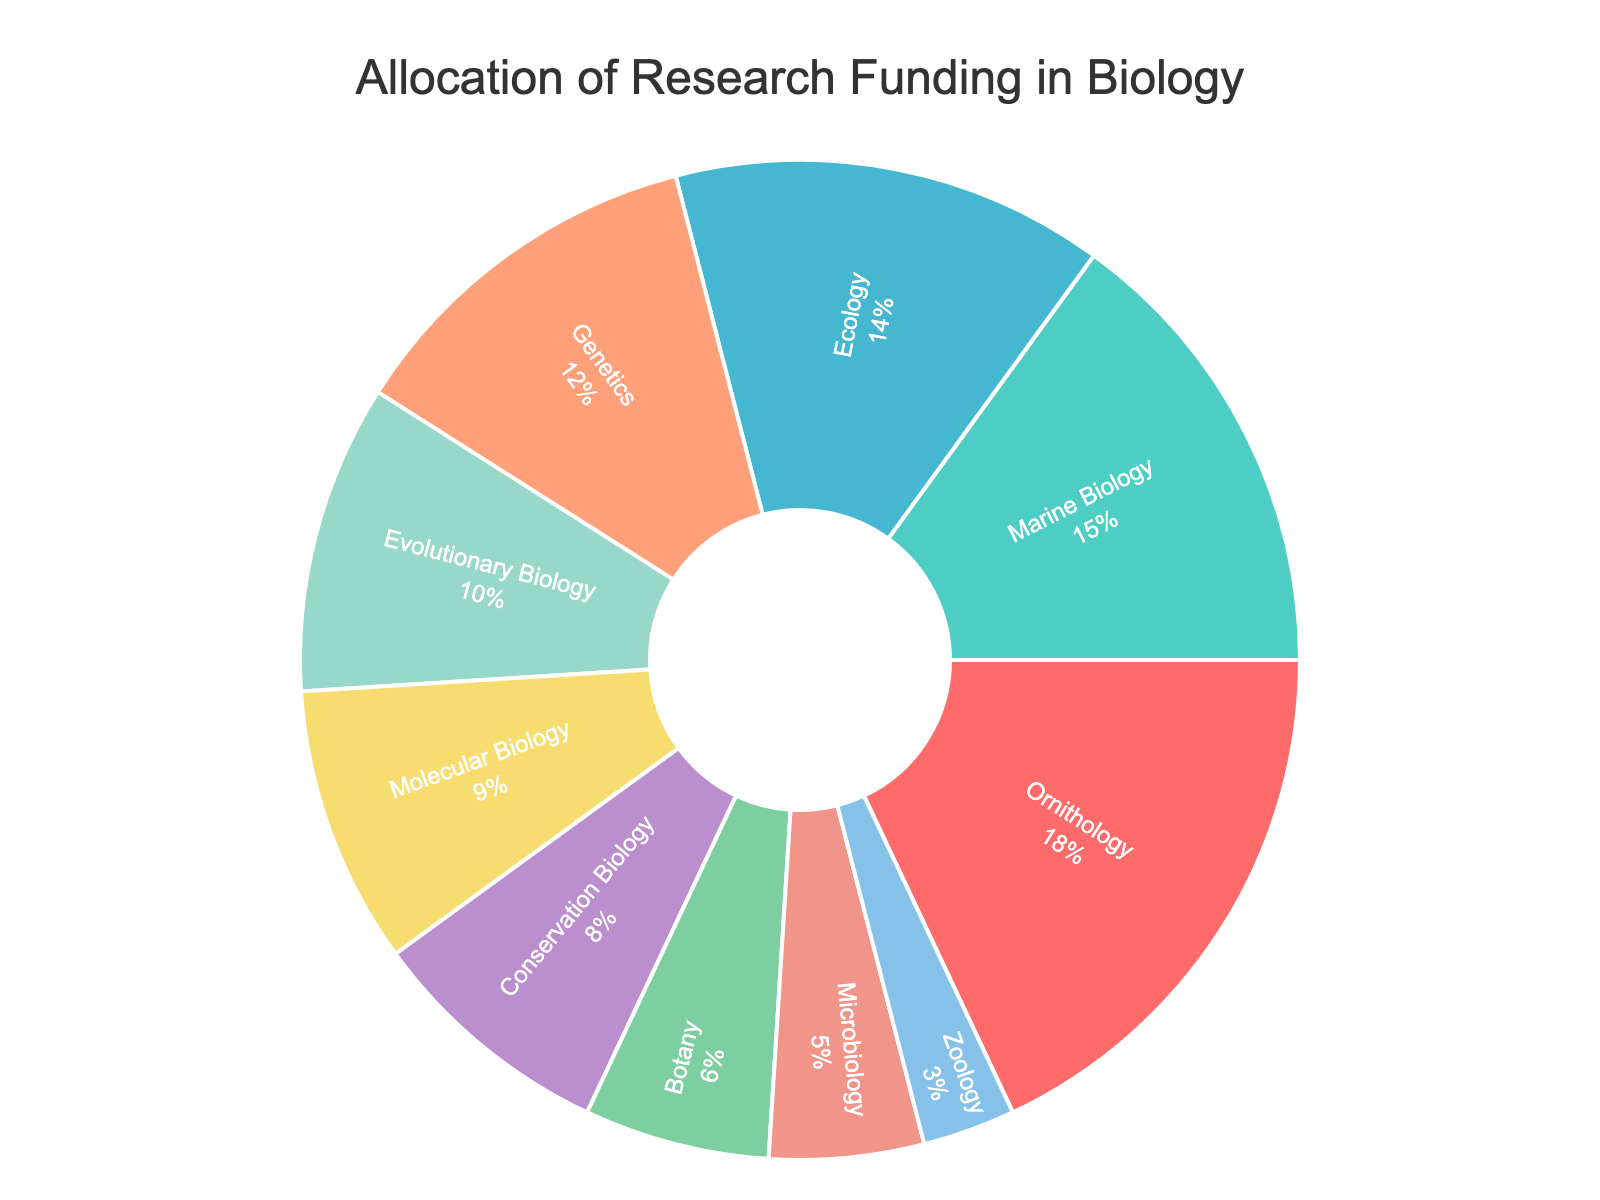Which field within biology receives the highest proportion of research funding? By looking at the figure, the section labeled "Ornithology" receives 18% of the funding, which is the largest percentage.
Answer: Ornithology Which field receives the least research funding? The chart shows that "Zoology" receives the smallest portion, indicated by the label "3%".
Answer: Zoology What is the total percentage of research funding allocated to Genetics and Molecular Biology combined? Add the funding percentages for Genetics (12%) and Molecular Biology (9%). 12% + 9% = 21%.
Answer: 21% Compare the funding for Ecology and Botany. Which gets more, and by how much? From the chart, Ecology gets 14% and Botany gets 6%. The difference is 14% - 6% = 8%.
Answer: Ecology by 8% Is Marine Biology funded more or less than Conservation Biology? The figure shows Marine Biology receives 15% of the funding while Conservation Biology gets 8%. 15% is greater than 8%.
Answer: More What is the difference in funding between Evolutionary Biology and Microbiology? Evolutionary Biology receives 10% and Microbiology receives 5%. The difference is 10% - 5% = 5%.
Answer: 5% Which fields receive less than 10% of the funding? By examining the figure, the fields with less than 10% funding are Molecular Biology (9%), Conservation Biology (8%), Botany (6%), Microbiology (5%), and Zoology (3%).
Answer: Molecular Biology, Conservation Biology, Botany, Microbiology, Zoology What percentage of the total funding is allocated to the three fields with the smallest allocations combined? Add the funding percentages for Zoology (3%), Microbiology (5%), and Botany (6%). 3% + 5% + 6% = 14%.
Answer: 14% 